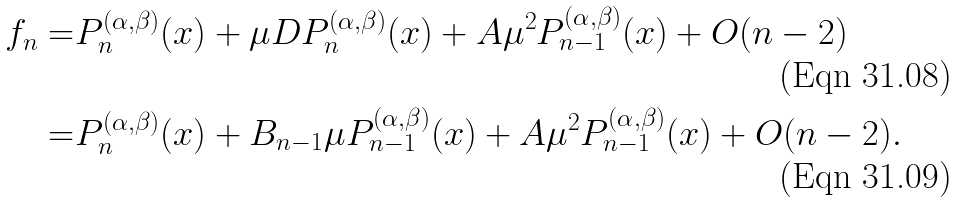Convert formula to latex. <formula><loc_0><loc_0><loc_500><loc_500>f _ { n } = & P _ { n } ^ { ( \alpha , \beta ) } ( x ) + \mu D P _ { n } ^ { ( \alpha , \beta ) } ( x ) + A \mu ^ { 2 } P _ { n - 1 } ^ { ( \alpha , \beta ) } ( x ) + O ( n - 2 ) \\ = & P _ { n } ^ { ( \alpha , \beta ) } ( x ) + B _ { n - 1 } \mu P _ { n - 1 } ^ { ( \alpha , \beta ) } ( x ) + A \mu ^ { 2 } P _ { n - 1 } ^ { ( \alpha , \beta ) } ( x ) + O ( n - 2 ) .</formula> 